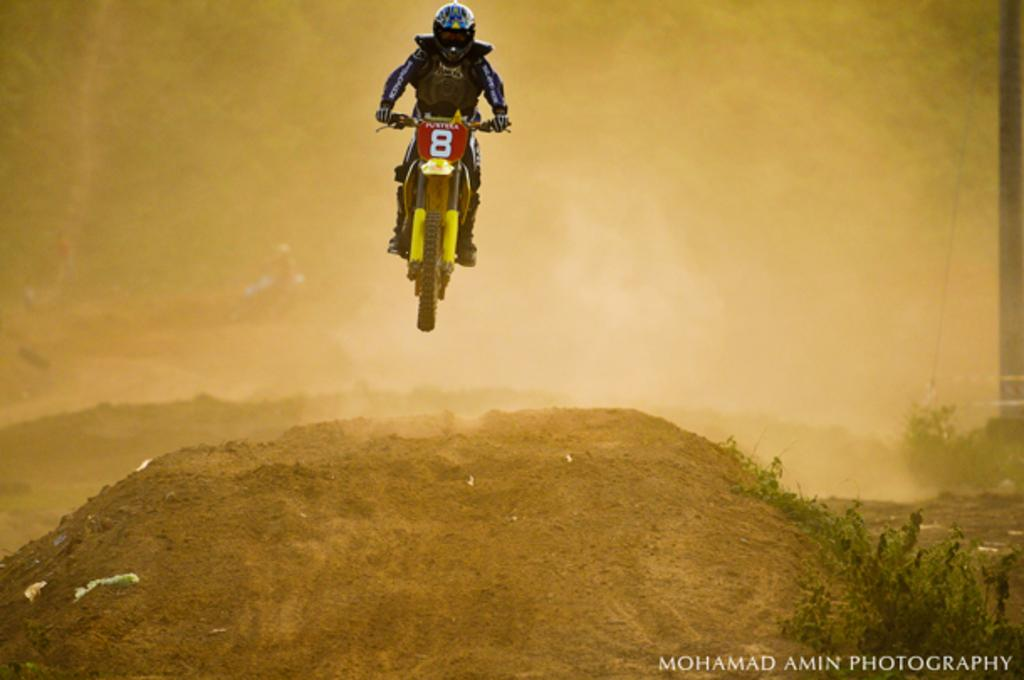Who is present in the image? There is a person in the image. What is the person doing or with whom in the image? The person is with a bike in the image. What type of environment is depicted in the image? The image shows plants and sand at the bottom, suggesting a beach or park setting. What type of bun is the person holding in the image? There is no bun present in the image; the person is with a bike. What joke is the person telling while riding the bike in the image? There is no indication of a joke being told in the image; the person is simply with a bike. 